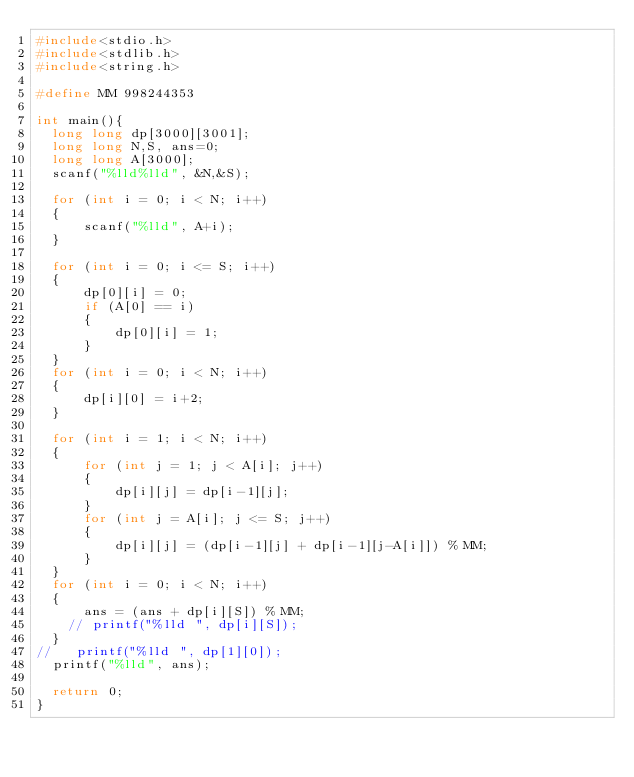<code> <loc_0><loc_0><loc_500><loc_500><_C_>#include<stdio.h>
#include<stdlib.h>
#include<string.h>

#define MM 998244353

int main(){
  long long dp[3000][3001];
  long long N,S, ans=0;
  long long A[3000];
  scanf("%lld%lld", &N,&S);

  for (int i = 0; i < N; i++)
  {
      scanf("%lld", A+i);
  }

  for (int i = 0; i <= S; i++)
  {
      dp[0][i] = 0;
      if (A[0] == i)
      {
          dp[0][i] = 1;
      }
  }
  for (int i = 0; i < N; i++)
  {
      dp[i][0] = i+2;
  }
  
  for (int i = 1; i < N; i++)
  {
      for (int j = 1; j < A[i]; j++)
      {
          dp[i][j] = dp[i-1][j];
      }
      for (int j = A[i]; j <= S; j++)
      {
          dp[i][j] = (dp[i-1][j] + dp[i-1][j-A[i]]) % MM;
      }
  }
  for (int i = 0; i < N; i++)
  {
      ans = (ans + dp[i][S]) % MM;
    // printf("%lld ", dp[i][S]);
  }
//   printf("%lld ", dp[1][0]);
  printf("%lld", ans);

  return 0;
}</code> 